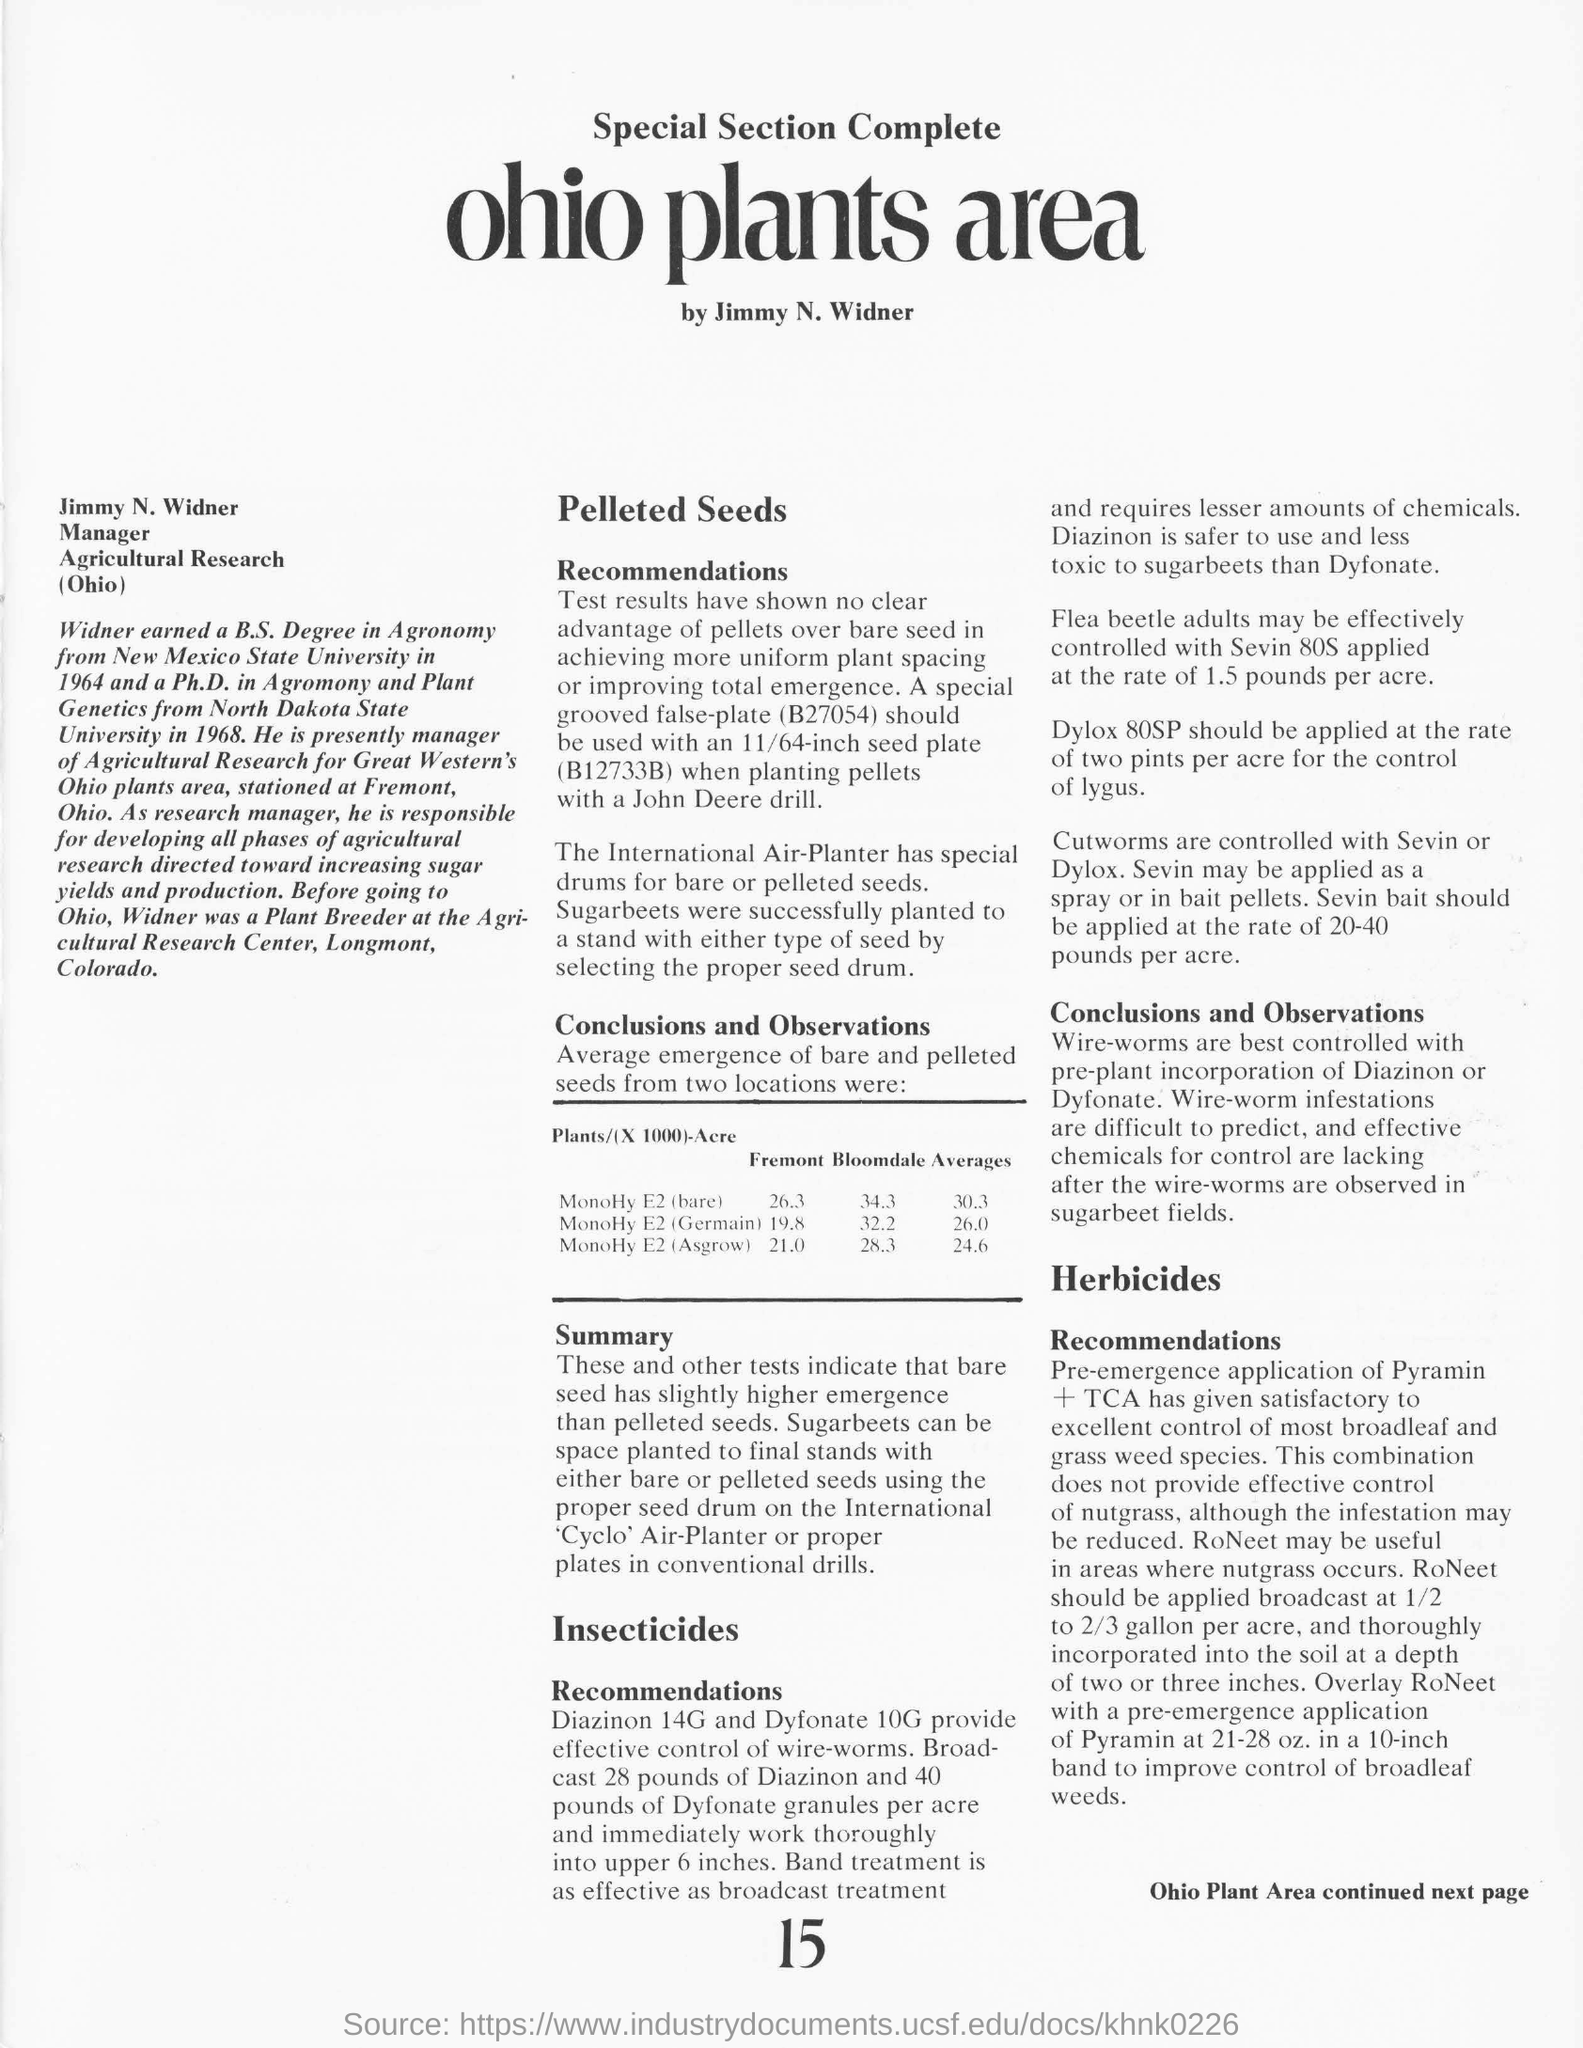Specify some key components in this picture. The insecticides Diazinon 14G and Dyfonate 10G are effective in controlling wire-worms, a common pest in agriculture. These insecticides have been shown to effectively prevent damage to crops and improve yield. Jimmy N. Widner is the manager of Agricultural Research in Ohio. According to the recommended application rate, two pints of Dylox 80SP should be used per acre to effectively control lygus pests. The average emergence of MonoHy E2(bare) seeds from Fremont and Bloomdale fields is 30.3%. 